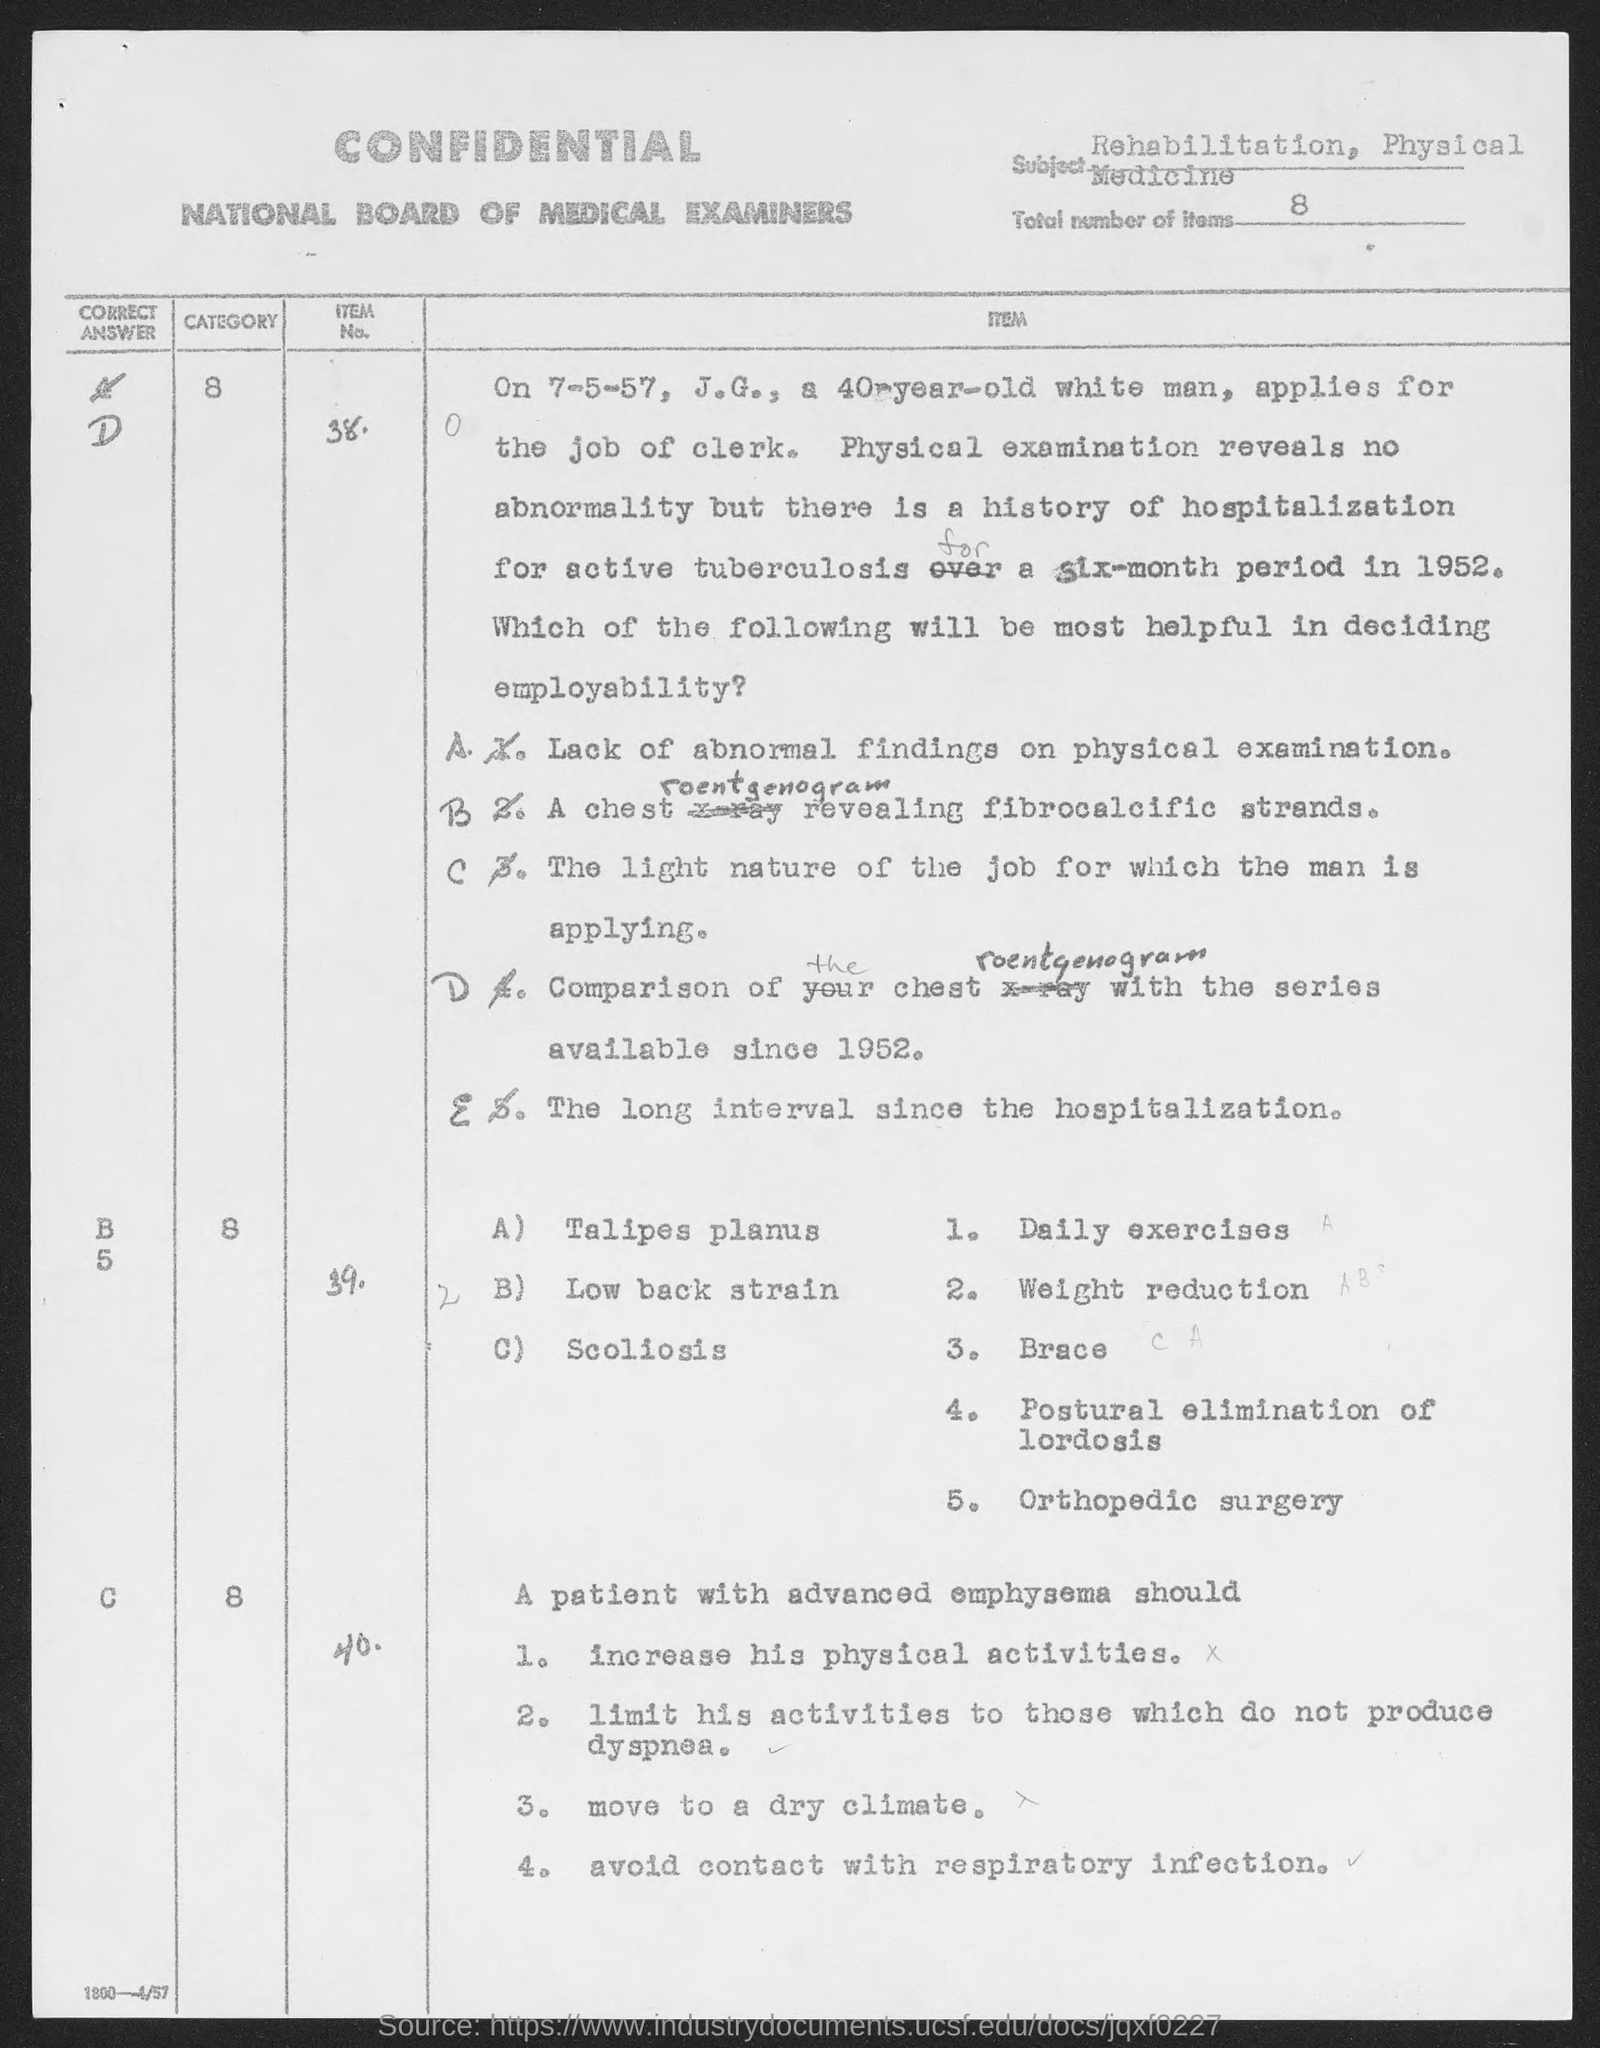What is the subject mentioned in the given page ?
Keep it short and to the point. Rehabilitation , physical medicine. What are the total no. of items mentioned in the given page ?
Keep it short and to the point. 8. What is the name of the examiners mentioned in the given page ?
Give a very brief answer. National board of medical examiners. 